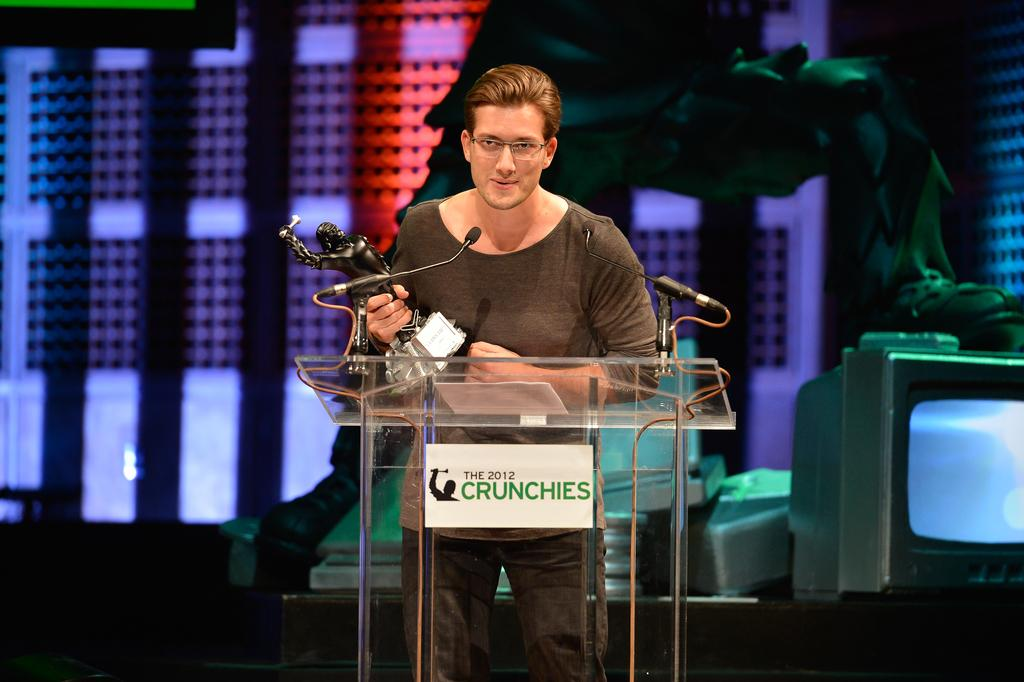<image>
Share a concise interpretation of the image provided. A man holding up an award at the 2012 Crunchies. 